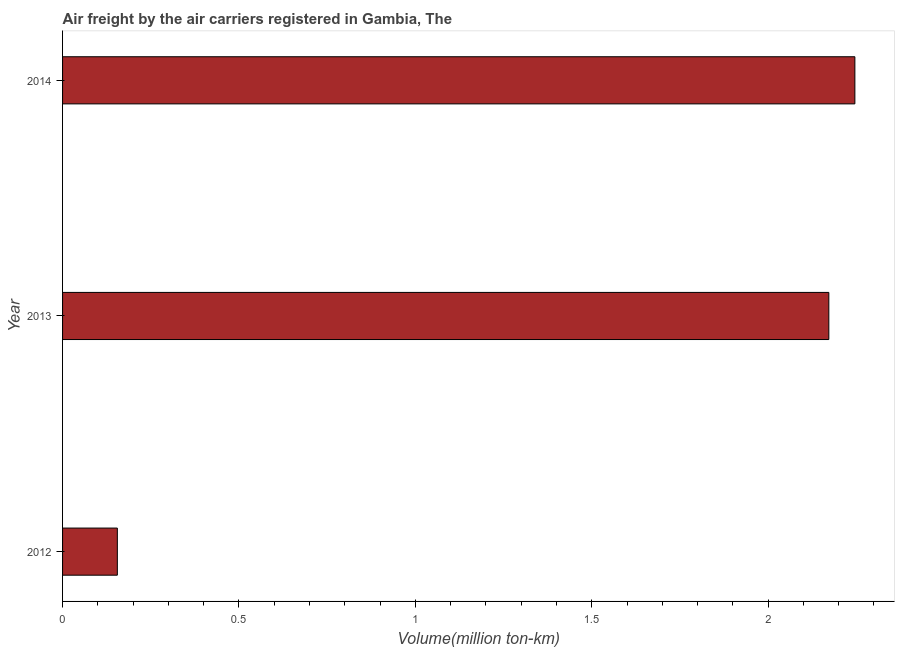Does the graph contain any zero values?
Your answer should be compact. No. What is the title of the graph?
Make the answer very short. Air freight by the air carriers registered in Gambia, The. What is the label or title of the X-axis?
Make the answer very short. Volume(million ton-km). What is the label or title of the Y-axis?
Offer a terse response. Year. What is the air freight in 2013?
Your response must be concise. 2.17. Across all years, what is the maximum air freight?
Your answer should be compact. 2.25. Across all years, what is the minimum air freight?
Provide a succinct answer. 0.16. In which year was the air freight maximum?
Your response must be concise. 2014. In which year was the air freight minimum?
Offer a very short reply. 2012. What is the sum of the air freight?
Provide a short and direct response. 4.57. What is the difference between the air freight in 2012 and 2013?
Keep it short and to the point. -2.02. What is the average air freight per year?
Provide a succinct answer. 1.52. What is the median air freight?
Give a very brief answer. 2.17. Do a majority of the years between 2014 and 2012 (inclusive) have air freight greater than 1.2 million ton-km?
Provide a succinct answer. Yes. What is the ratio of the air freight in 2012 to that in 2013?
Keep it short and to the point. 0.07. Is the air freight in 2012 less than that in 2014?
Your response must be concise. Yes. Is the difference between the air freight in 2013 and 2014 greater than the difference between any two years?
Your answer should be very brief. No. What is the difference between the highest and the second highest air freight?
Provide a succinct answer. 0.07. Is the sum of the air freight in 2012 and 2014 greater than the maximum air freight across all years?
Your response must be concise. Yes. What is the difference between the highest and the lowest air freight?
Your response must be concise. 2.09. How many bars are there?
Make the answer very short. 3. What is the difference between two consecutive major ticks on the X-axis?
Give a very brief answer. 0.5. What is the Volume(million ton-km) of 2012?
Your answer should be compact. 0.16. What is the Volume(million ton-km) of 2013?
Your response must be concise. 2.17. What is the Volume(million ton-km) of 2014?
Make the answer very short. 2.25. What is the difference between the Volume(million ton-km) in 2012 and 2013?
Your answer should be compact. -2.02. What is the difference between the Volume(million ton-km) in 2012 and 2014?
Keep it short and to the point. -2.09. What is the difference between the Volume(million ton-km) in 2013 and 2014?
Keep it short and to the point. -0.07. What is the ratio of the Volume(million ton-km) in 2012 to that in 2013?
Your response must be concise. 0.07. What is the ratio of the Volume(million ton-km) in 2012 to that in 2014?
Your response must be concise. 0.07. 